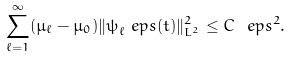Convert formula to latex. <formula><loc_0><loc_0><loc_500><loc_500>\sum _ { \ell = 1 } ^ { \infty } ( \mu _ { \ell } - \mu _ { 0 } ) \| \psi _ { \ell } ^ { \ } e p s ( t ) \| _ { L ^ { 2 } } ^ { 2 } \leq C \ e p s ^ { 2 } .</formula> 